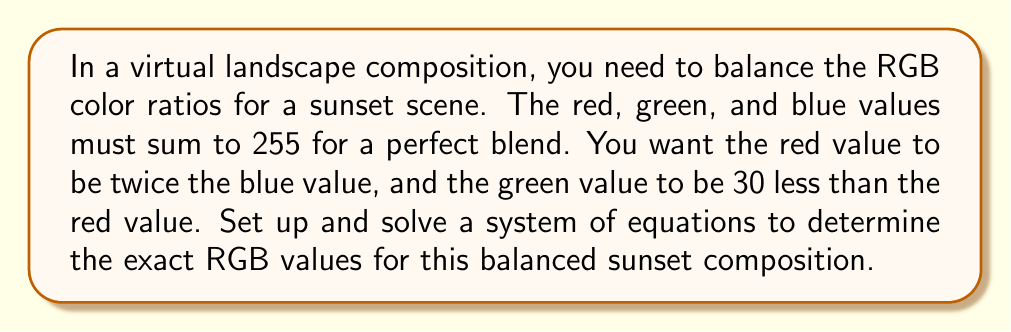Solve this math problem. Let's approach this step-by-step:

1) Let's define our variables:
   $r$ = red value
   $g$ = green value
   $b$ = blue value

2) Now, we can set up our system of equations based on the given conditions:

   $$\begin{cases}
   r + g + b = 255 & \text{(sum to 255)}\\
   r = 2b & \text{(red is twice blue)}\\
   g = r - 30 & \text{(green is 30 less than red)}
   \end{cases}$$

3) Let's substitute the second and third equations into the first:

   $2b + (2b - 30) + b = 255$

4) Simplify:

   $2b + 2b - 30 + b = 255$
   $5b - 30 = 255$

5) Solve for $b$:

   $5b = 285$
   $b = 57$

6) Now that we know $b$, we can find $r$ and $g$:

   $r = 2b = 2(57) = 114$
   $g = r - 30 = 114 - 30 = 84$

7) Let's verify that these values sum to 255:

   $114 + 84 + 57 = 255$

Therefore, the balanced RGB values for the sunset composition are:
Red: 114, Green: 84, Blue: 57
Answer: (114, 84, 57) 